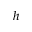<formula> <loc_0><loc_0><loc_500><loc_500>h</formula> 